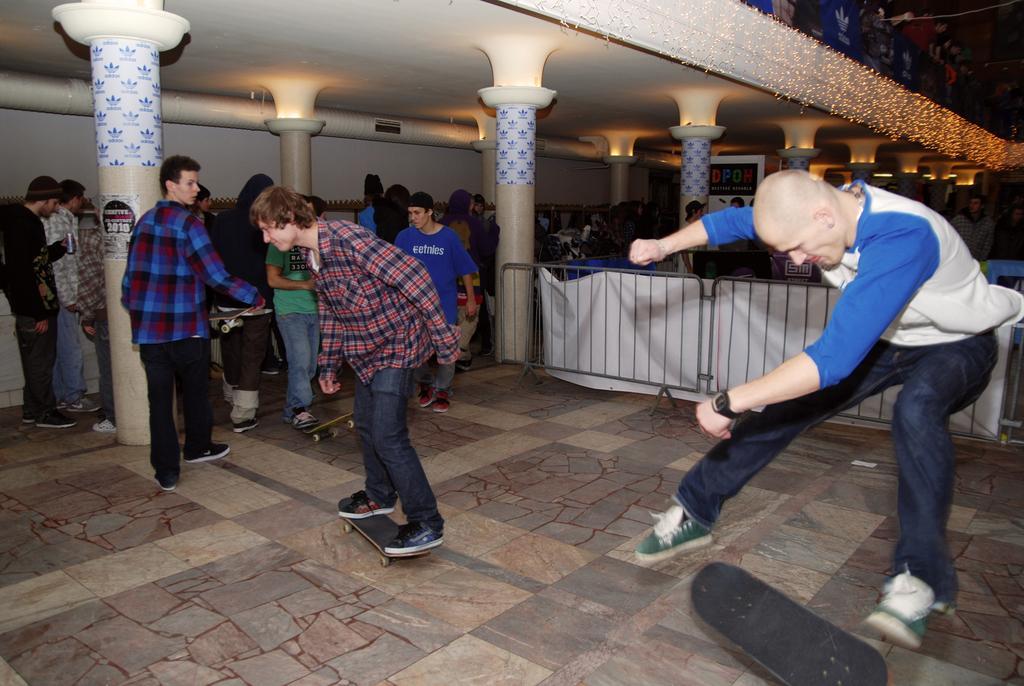Could you give a brief overview of what you see in this image? In this image there are people skating on skating board on a floor, in the background there are people standing and there are pillars, railing and lights. 